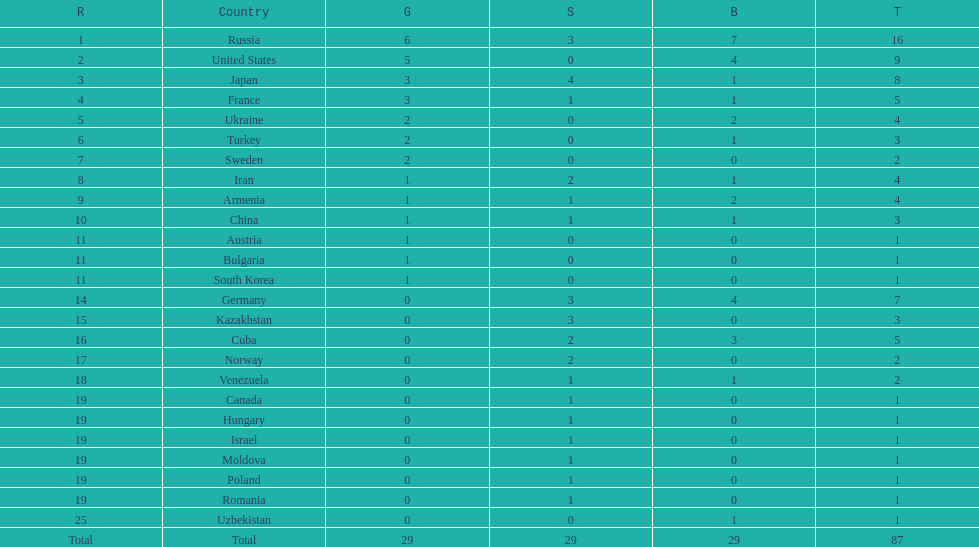Japan and france each won how many gold medals? 3. 